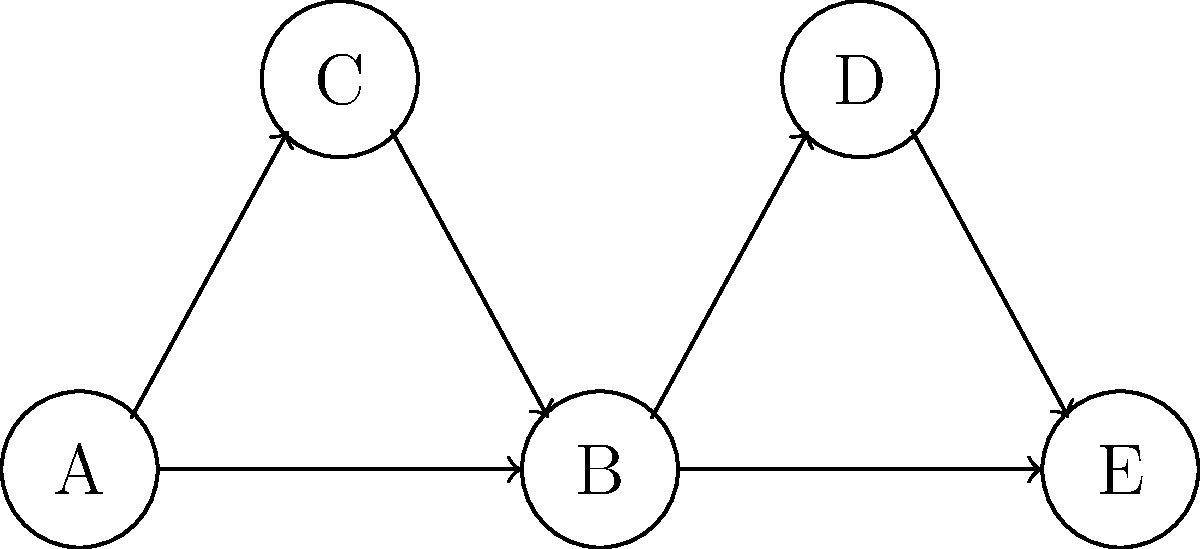In the directed graph representing a playlist structure, what is the maximum number of songs that can be played before reaching a song with no outgoing edges (i.e., the last song in a sequence)? To find the maximum number of songs that can be played before reaching a song with no outgoing edges, we need to identify the longest path in the directed graph. Let's analyze the graph step-by-step:

1. Start by identifying the nodes with no outgoing edges (sinks):
   - Node E has no outgoing edges, so it's a sink.

2. Now, let's trace all possible paths from each starting node:
   - Path from A: A → B → E (3 songs)
   - Path from A: A → C → B → E (4 songs)
   - Path from B: B → E (2 songs)
   - Path from B: B → D → E (3 songs)
   - Path from C: C → B → E (3 songs)
   - Path from D: D → E (2 songs)

3. The longest path we've found is: A → C → B → E, which consists of 4 songs.

Therefore, the maximum number of songs that can be played before reaching a song with no outgoing edges (E in this case) is 4.
Answer: 4 